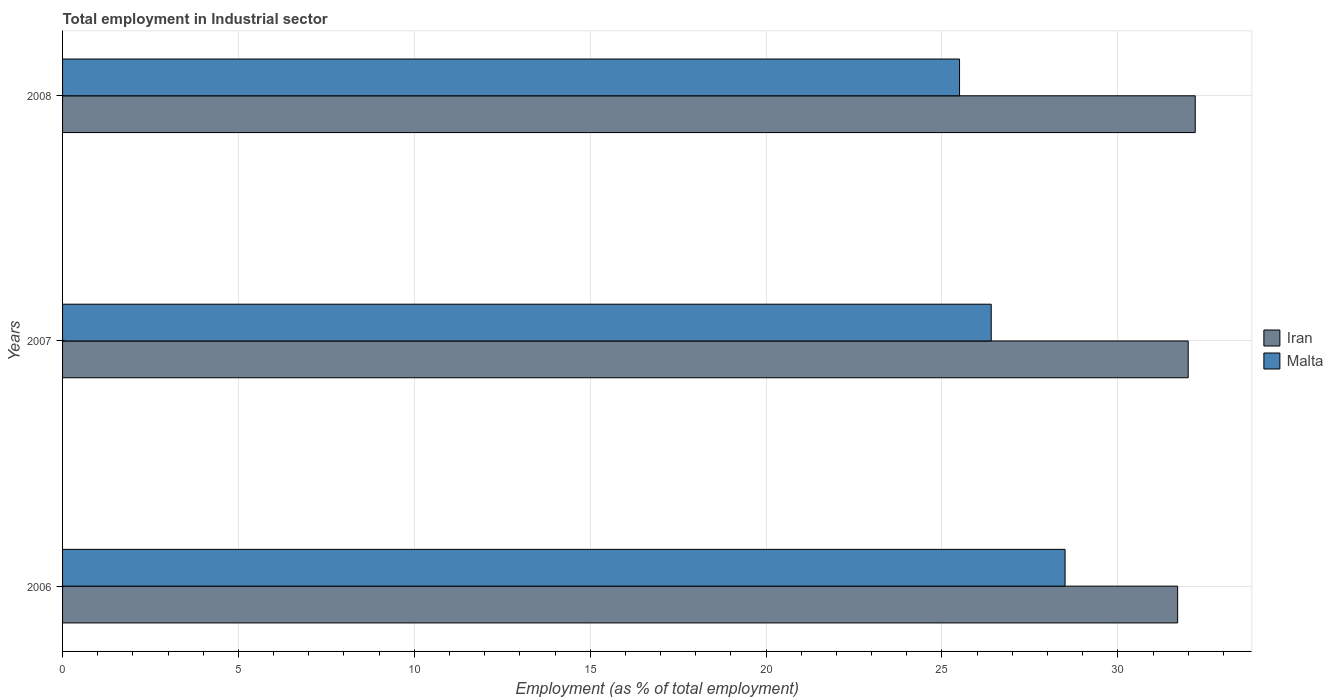How many bars are there on the 2nd tick from the bottom?
Your answer should be very brief. 2. What is the label of the 1st group of bars from the top?
Provide a succinct answer. 2008. What is the employment in industrial sector in Malta in 2006?
Keep it short and to the point. 28.5. Across all years, what is the maximum employment in industrial sector in Iran?
Ensure brevity in your answer.  32.2. Across all years, what is the minimum employment in industrial sector in Malta?
Offer a terse response. 25.5. In which year was the employment in industrial sector in Malta maximum?
Your answer should be compact. 2006. In which year was the employment in industrial sector in Iran minimum?
Provide a succinct answer. 2006. What is the total employment in industrial sector in Iran in the graph?
Offer a very short reply. 95.9. What is the difference between the employment in industrial sector in Malta in 2006 and that in 2008?
Provide a short and direct response. 3. What is the average employment in industrial sector in Iran per year?
Make the answer very short. 31.97. In the year 2008, what is the difference between the employment in industrial sector in Malta and employment in industrial sector in Iran?
Your answer should be compact. -6.7. What is the ratio of the employment in industrial sector in Iran in 2006 to that in 2008?
Make the answer very short. 0.98. Is the difference between the employment in industrial sector in Malta in 2007 and 2008 greater than the difference between the employment in industrial sector in Iran in 2007 and 2008?
Your answer should be compact. Yes. What is the difference between the highest and the second highest employment in industrial sector in Iran?
Provide a short and direct response. 0.2. What is the difference between the highest and the lowest employment in industrial sector in Malta?
Offer a very short reply. 3. In how many years, is the employment in industrial sector in Iran greater than the average employment in industrial sector in Iran taken over all years?
Make the answer very short. 2. Is the sum of the employment in industrial sector in Malta in 2006 and 2008 greater than the maximum employment in industrial sector in Iran across all years?
Offer a very short reply. Yes. What does the 1st bar from the top in 2008 represents?
Give a very brief answer. Malta. What does the 2nd bar from the bottom in 2008 represents?
Offer a terse response. Malta. How many bars are there?
Provide a short and direct response. 6. Are all the bars in the graph horizontal?
Provide a succinct answer. Yes. Does the graph contain any zero values?
Keep it short and to the point. No. Does the graph contain grids?
Ensure brevity in your answer.  Yes. Where does the legend appear in the graph?
Offer a terse response. Center right. How many legend labels are there?
Offer a very short reply. 2. How are the legend labels stacked?
Make the answer very short. Vertical. What is the title of the graph?
Provide a succinct answer. Total employment in Industrial sector. Does "Latin America(all income levels)" appear as one of the legend labels in the graph?
Your response must be concise. No. What is the label or title of the X-axis?
Your answer should be very brief. Employment (as % of total employment). What is the Employment (as % of total employment) in Iran in 2006?
Your answer should be very brief. 31.7. What is the Employment (as % of total employment) of Malta in 2006?
Make the answer very short. 28.5. What is the Employment (as % of total employment) in Malta in 2007?
Provide a short and direct response. 26.4. What is the Employment (as % of total employment) in Iran in 2008?
Offer a very short reply. 32.2. Across all years, what is the maximum Employment (as % of total employment) in Iran?
Provide a short and direct response. 32.2. Across all years, what is the maximum Employment (as % of total employment) in Malta?
Your response must be concise. 28.5. Across all years, what is the minimum Employment (as % of total employment) of Iran?
Keep it short and to the point. 31.7. What is the total Employment (as % of total employment) of Iran in the graph?
Provide a short and direct response. 95.9. What is the total Employment (as % of total employment) in Malta in the graph?
Provide a succinct answer. 80.4. What is the difference between the Employment (as % of total employment) of Iran in 2006 and that in 2007?
Provide a short and direct response. -0.3. What is the difference between the Employment (as % of total employment) of Malta in 2006 and that in 2008?
Make the answer very short. 3. What is the average Employment (as % of total employment) of Iran per year?
Your answer should be compact. 31.97. What is the average Employment (as % of total employment) of Malta per year?
Keep it short and to the point. 26.8. In the year 2006, what is the difference between the Employment (as % of total employment) in Iran and Employment (as % of total employment) in Malta?
Keep it short and to the point. 3.2. What is the ratio of the Employment (as % of total employment) of Iran in 2006 to that in 2007?
Your response must be concise. 0.99. What is the ratio of the Employment (as % of total employment) in Malta in 2006 to that in 2007?
Provide a succinct answer. 1.08. What is the ratio of the Employment (as % of total employment) of Iran in 2006 to that in 2008?
Your answer should be very brief. 0.98. What is the ratio of the Employment (as % of total employment) of Malta in 2006 to that in 2008?
Offer a terse response. 1.12. What is the ratio of the Employment (as % of total employment) of Iran in 2007 to that in 2008?
Your answer should be compact. 0.99. What is the ratio of the Employment (as % of total employment) in Malta in 2007 to that in 2008?
Your response must be concise. 1.04. What is the difference between the highest and the second highest Employment (as % of total employment) of Malta?
Provide a succinct answer. 2.1. What is the difference between the highest and the lowest Employment (as % of total employment) of Malta?
Offer a terse response. 3. 